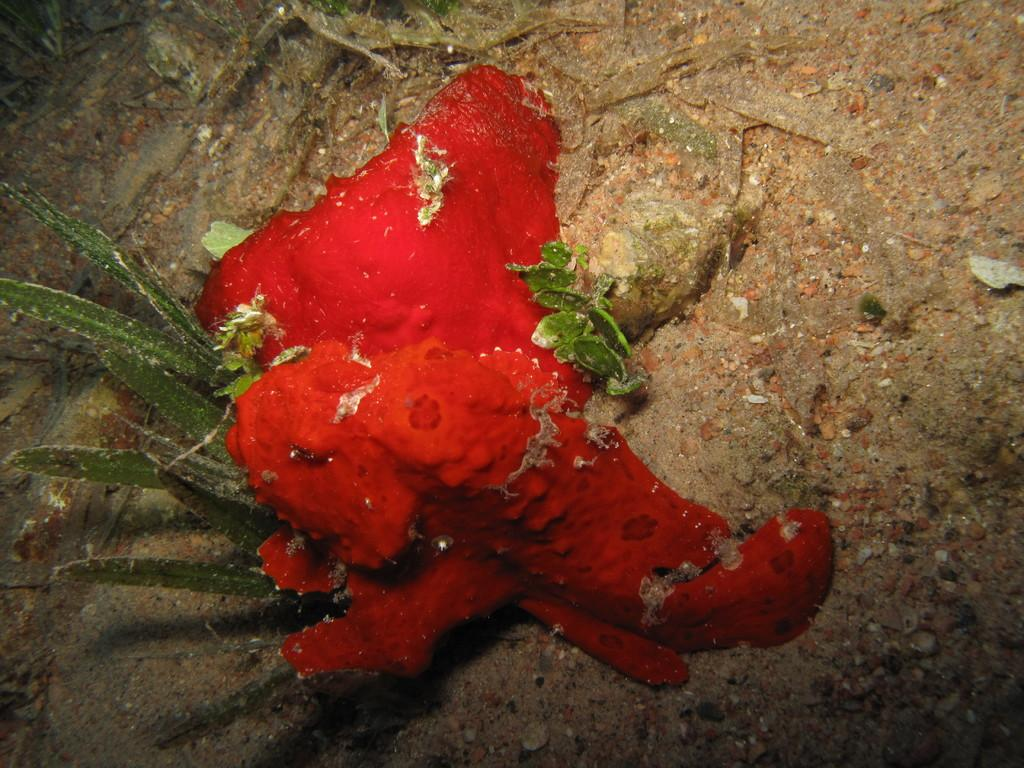What type of living organism can be seen in the picture? There is a plant in the picture. What color is the object on the ground in the image? The object on the ground is red. What type of oven is used by the daughter in the image? There is no oven or daughter present in the image. 